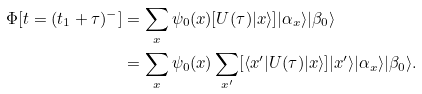Convert formula to latex. <formula><loc_0><loc_0><loc_500><loc_500>\Phi [ t = ( t _ { 1 } + \tau ) ^ { - } ] & = \sum _ { x } \psi _ { 0 } ( x ) [ U ( \tau ) | x \rangle ] | \alpha _ { x } \rangle | \beta _ { 0 } \rangle \\ & = \sum _ { x } \psi _ { 0 } ( x ) \sum _ { x ^ { \prime } } [ \langle x ^ { \prime } | U ( \tau ) | x \rangle ] | x ^ { \prime } \rangle | \alpha _ { x } \rangle | \beta _ { 0 } \rangle .</formula> 